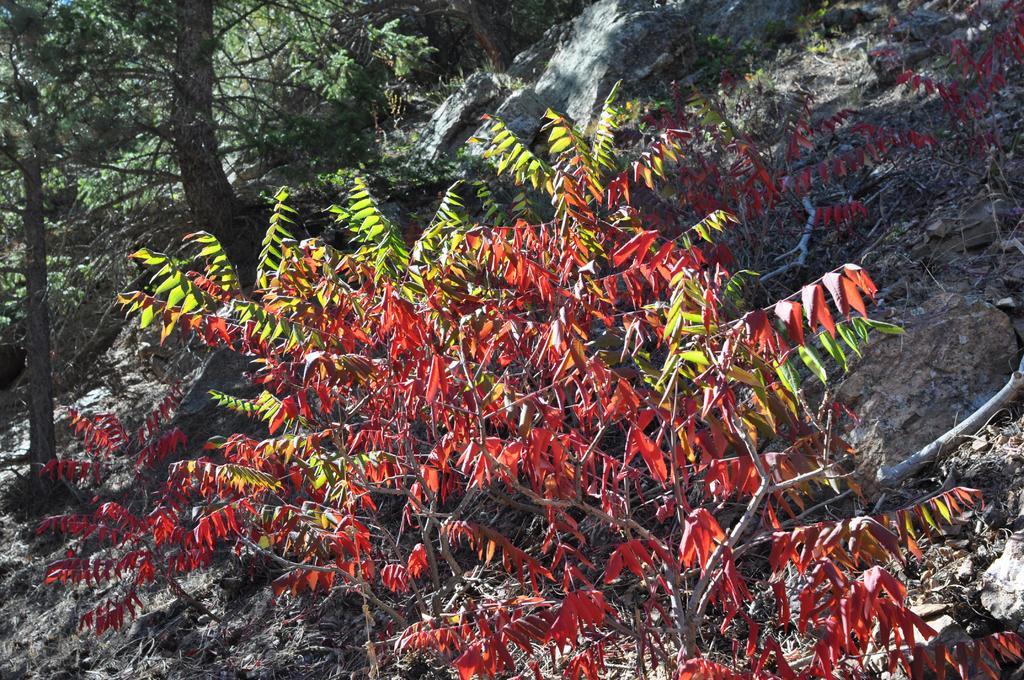How would you summarize this image in a sentence or two? In this picture we can see few trees and rocks. 